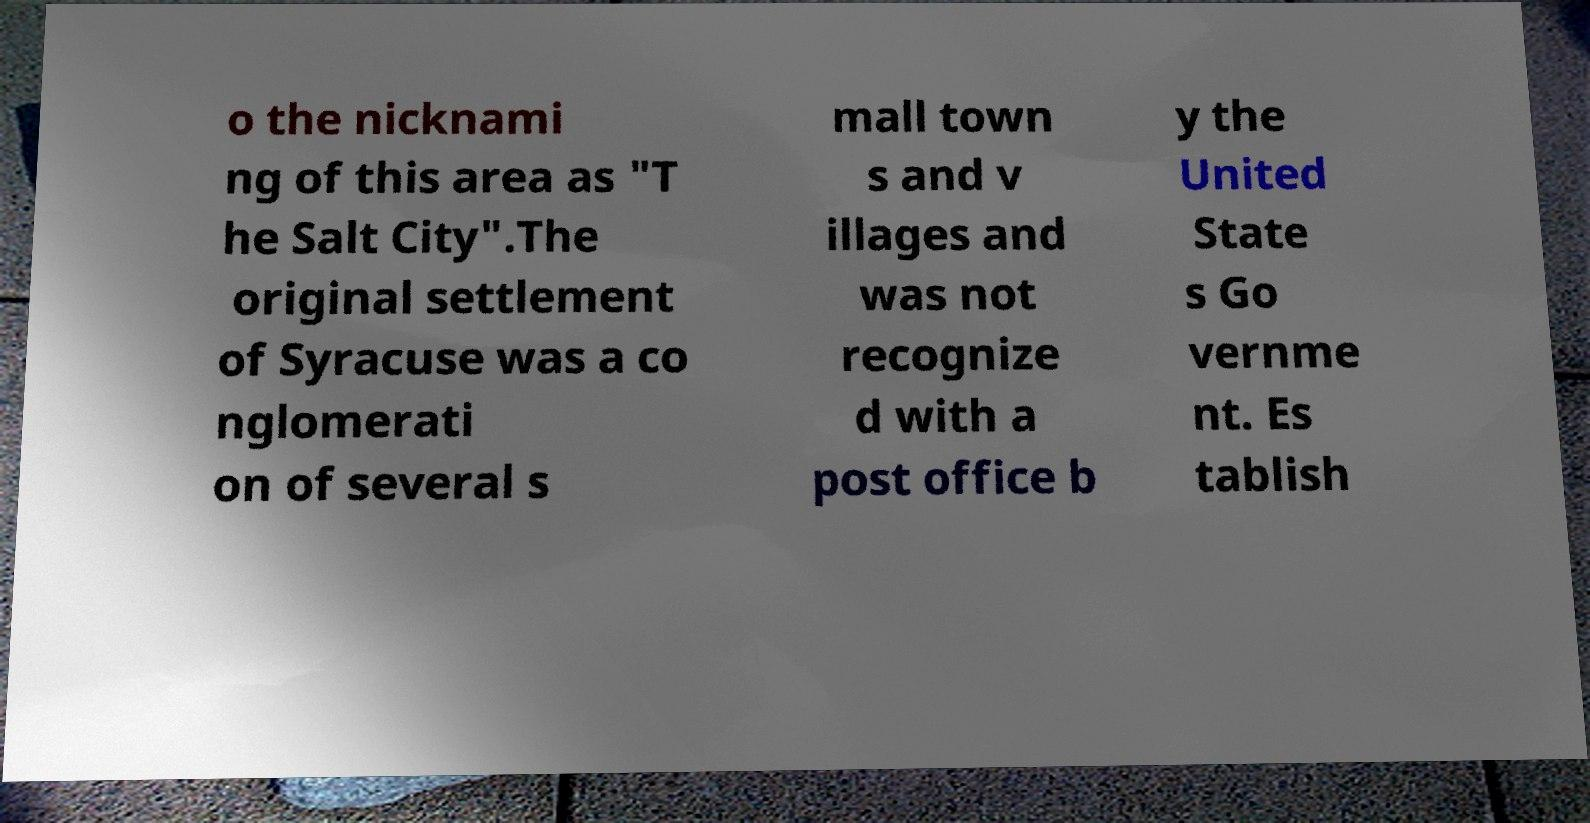There's text embedded in this image that I need extracted. Can you transcribe it verbatim? o the nicknami ng of this area as "T he Salt City".The original settlement of Syracuse was a co nglomerati on of several s mall town s and v illages and was not recognize d with a post office b y the United State s Go vernme nt. Es tablish 